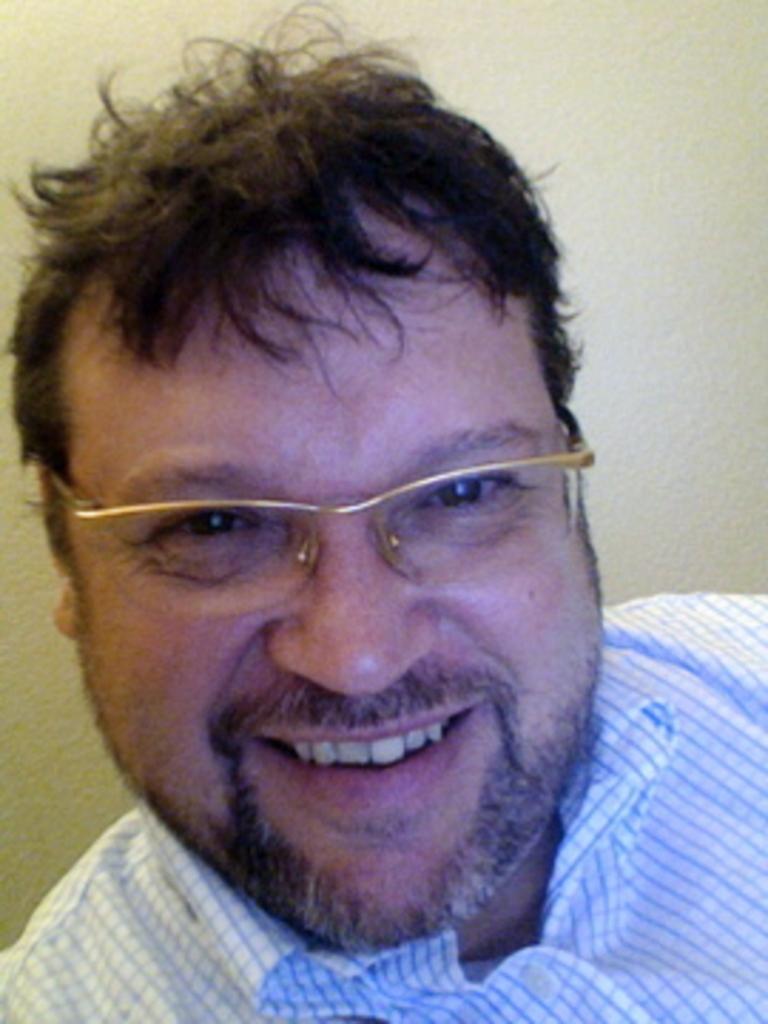In one or two sentences, can you explain what this image depicts? Here I can see a man wearing shirt, spectacles, smiling and giving pose for the picture. At the back of him there is a wall. 